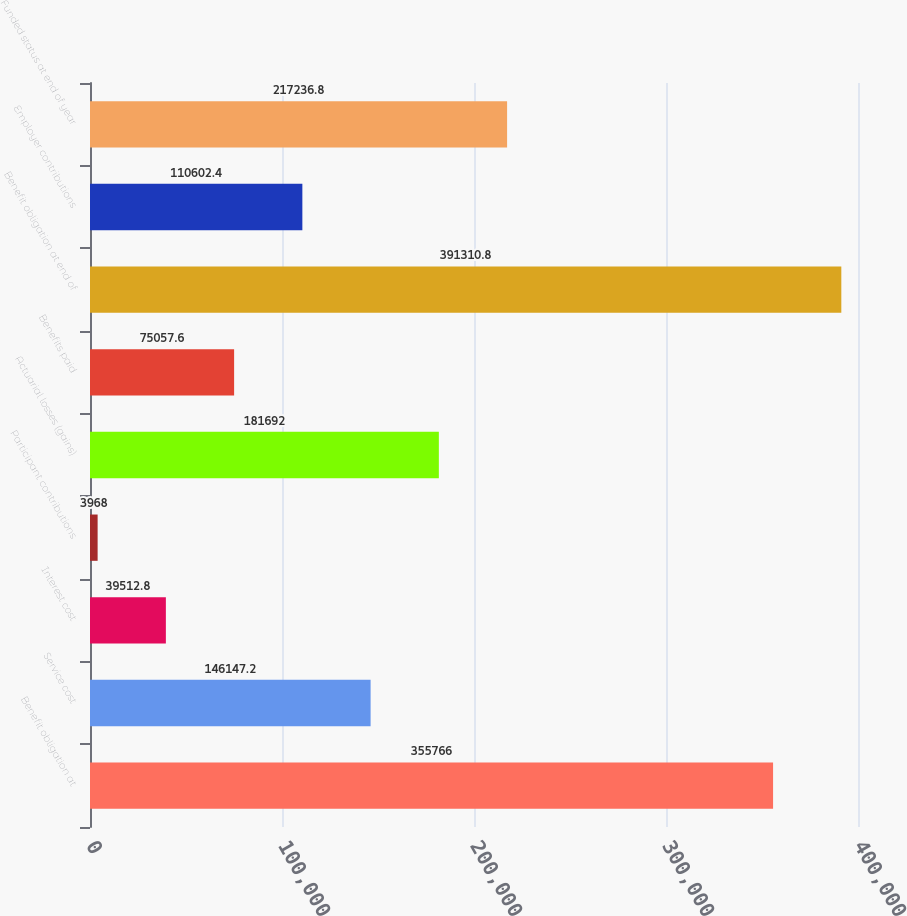Convert chart to OTSL. <chart><loc_0><loc_0><loc_500><loc_500><bar_chart><fcel>Benefit obligation at<fcel>Service cost<fcel>Interest cost<fcel>Participant contributions<fcel>Actuarial losses (gains)<fcel>Benefits paid<fcel>Benefit obligation at end of<fcel>Employer contributions<fcel>Funded status at end of year<nl><fcel>355766<fcel>146147<fcel>39512.8<fcel>3968<fcel>181692<fcel>75057.6<fcel>391311<fcel>110602<fcel>217237<nl></chart> 